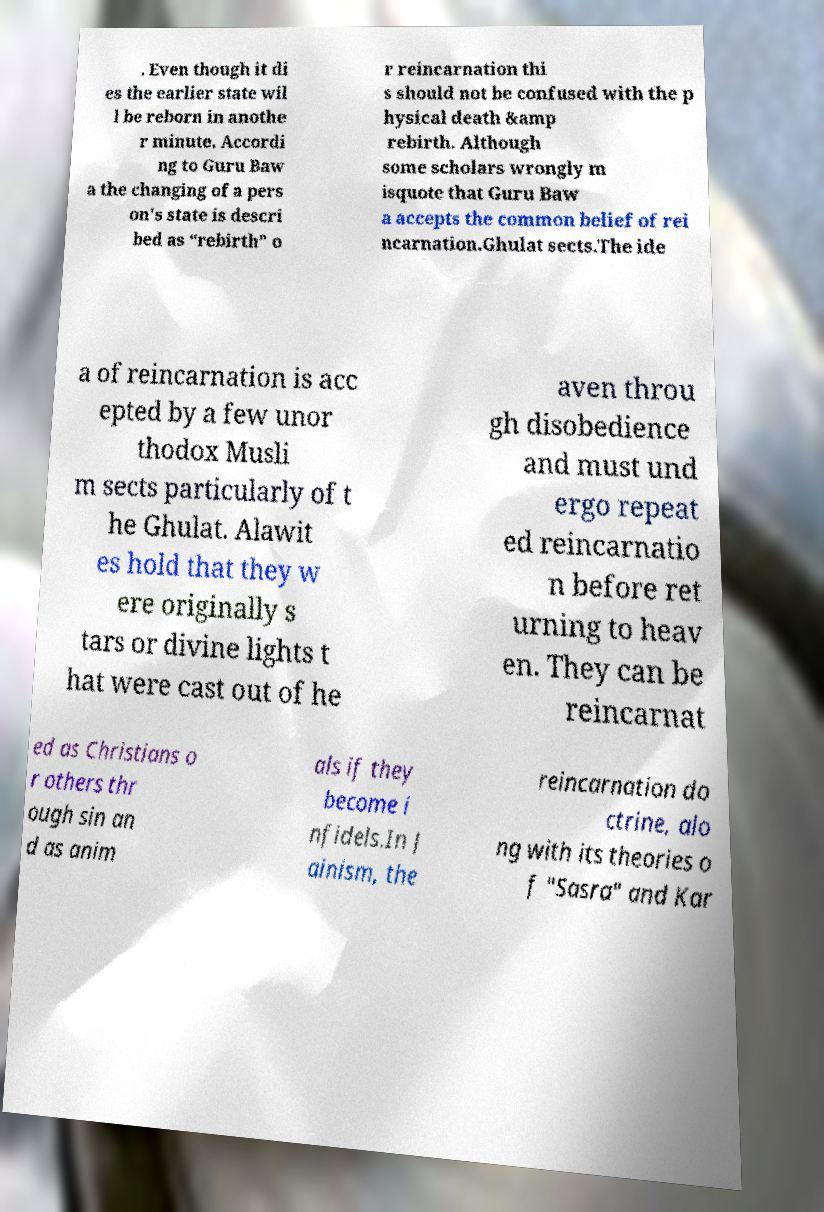Could you assist in decoding the text presented in this image and type it out clearly? . Even though it di es the earlier state wil l be reborn in anothe r minute. Accordi ng to Guru Baw a the changing of a pers on's state is descri bed as “rebirth” o r reincarnation thi s should not be confused with the p hysical death &amp rebirth. Although some scholars wrongly m isquote that Guru Baw a accepts the common belief of rei ncarnation.Ghulat sects.The ide a of reincarnation is acc epted by a few unor thodox Musli m sects particularly of t he Ghulat. Alawit es hold that they w ere originally s tars or divine lights t hat were cast out of he aven throu gh disobedience and must und ergo repeat ed reincarnatio n before ret urning to heav en. They can be reincarnat ed as Christians o r others thr ough sin an d as anim als if they become i nfidels.In J ainism, the reincarnation do ctrine, alo ng with its theories o f "Sasra" and Kar 